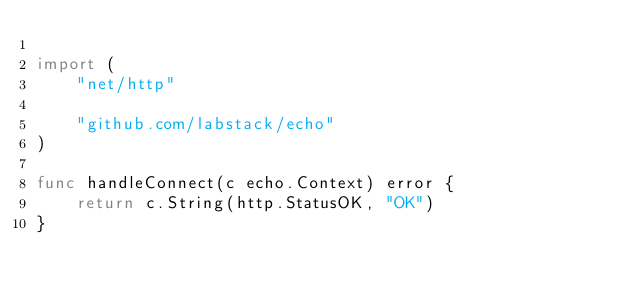Convert code to text. <code><loc_0><loc_0><loc_500><loc_500><_Go_>
import (
	"net/http"

	"github.com/labstack/echo"
)

func handleConnect(c echo.Context) error {
	return c.String(http.StatusOK, "OK")
}
</code> 